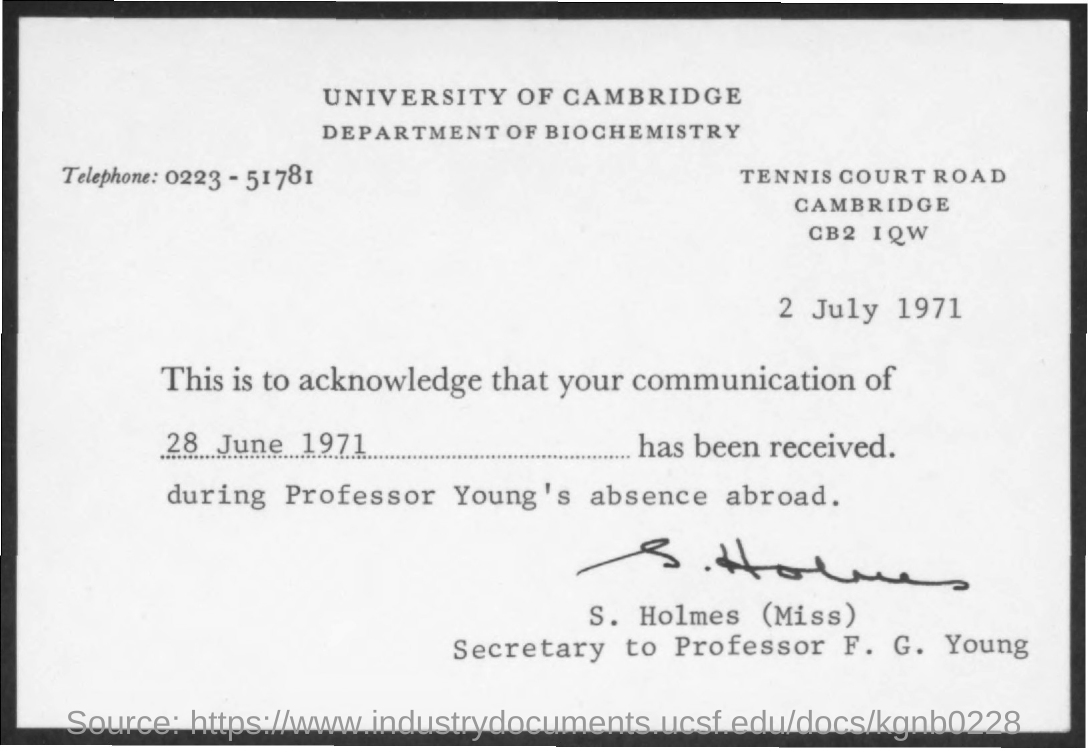What is the Telephone?
Keep it short and to the point. 0223-51781. What is the date on the document?
Your answer should be compact. 2 July 1971. Who is the letter from?
Provide a short and direct response. S. Holmes (Miss). 